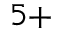<formula> <loc_0><loc_0><loc_500><loc_500>^ { 5 + }</formula> 